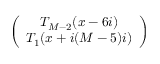Convert formula to latex. <formula><loc_0><loc_0><loc_500><loc_500>\left ( \begin{array} { c } { { T _ { M - 2 } ( x - 6 i ) } } \\ { { T _ { 1 } ( x + i ( M - 5 ) i ) } } \end{array} \right )</formula> 